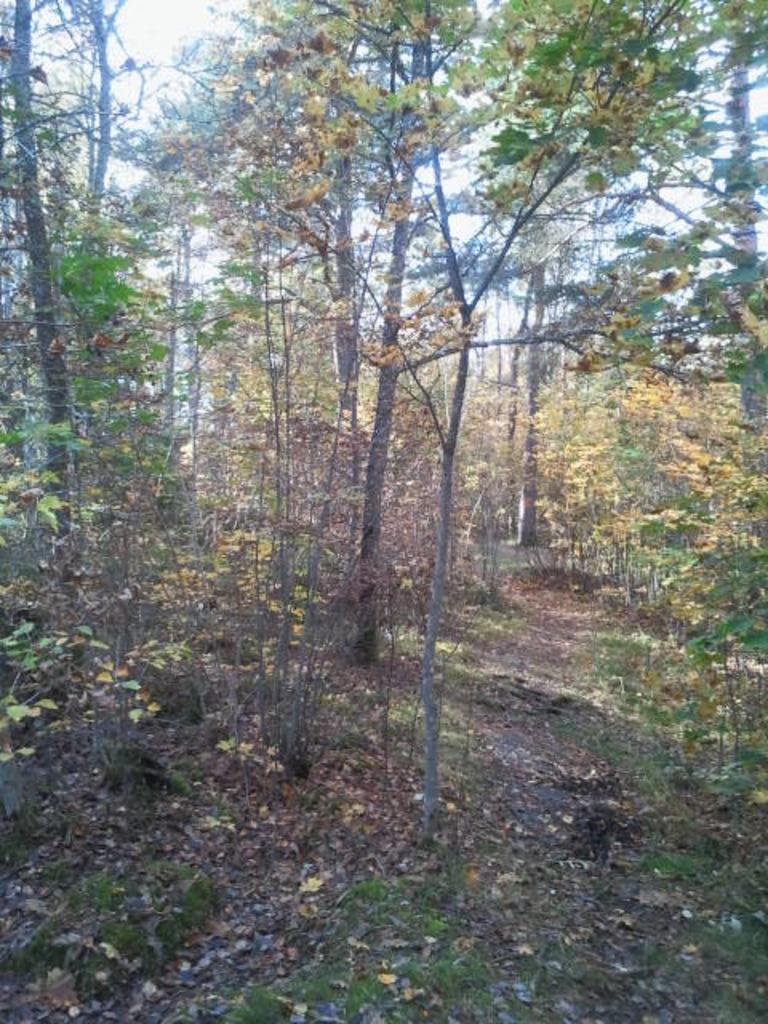Can you describe this image briefly? In this image we can see trees and sky. 